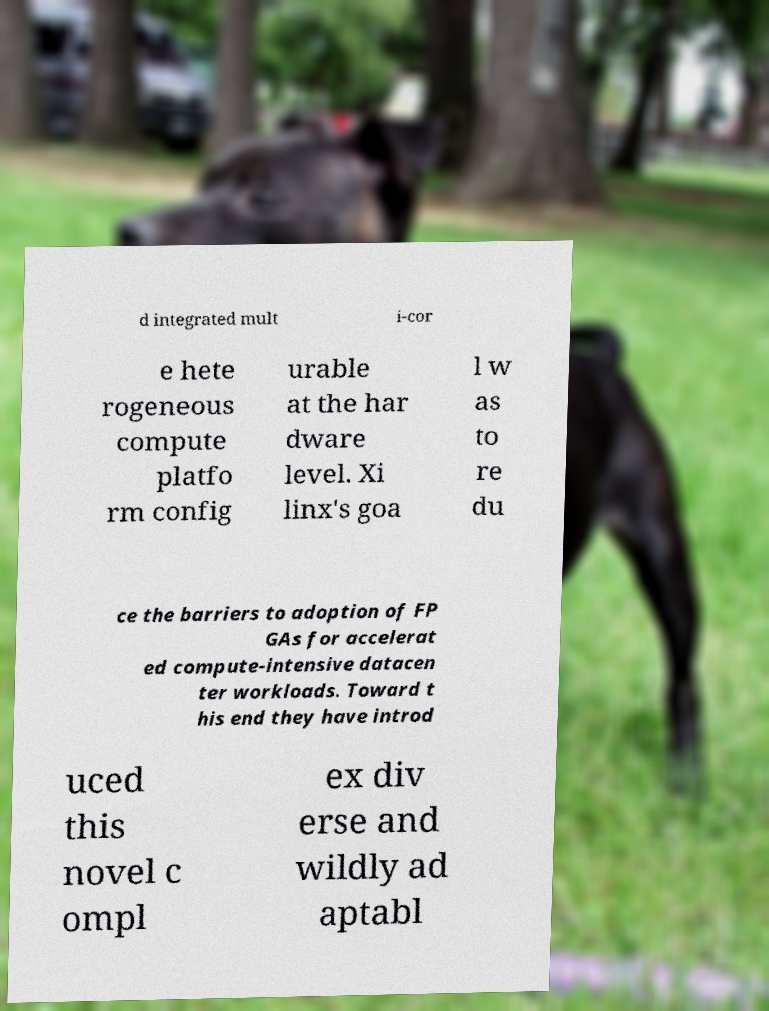Can you read and provide the text displayed in the image?This photo seems to have some interesting text. Can you extract and type it out for me? d integrated mult i-cor e hete rogeneous compute platfo rm config urable at the har dware level. Xi linx's goa l w as to re du ce the barriers to adoption of FP GAs for accelerat ed compute-intensive datacen ter workloads. Toward t his end they have introd uced this novel c ompl ex div erse and wildly ad aptabl 